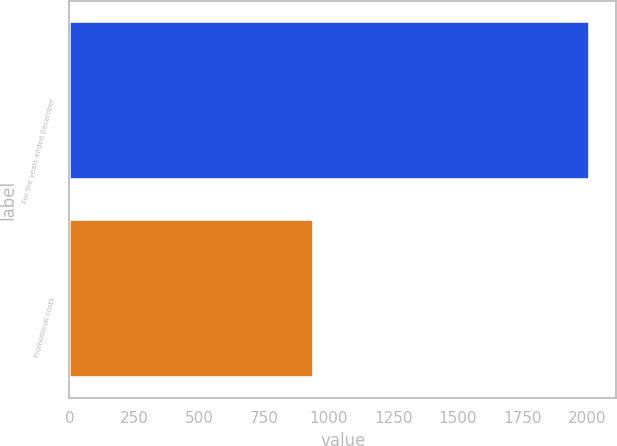<chart> <loc_0><loc_0><loc_500><loc_500><bar_chart><fcel>For the years ended December<fcel>Promotional costs<nl><fcel>2011<fcel>945.9<nl></chart> 